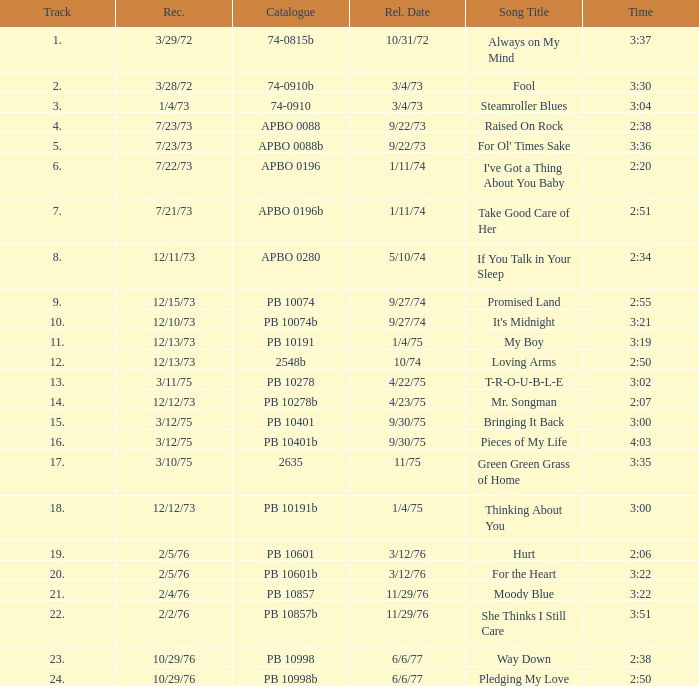Tell me the recorded for time of 2:50 and released date of 6/6/77 with track more than 20 10/29/76. 